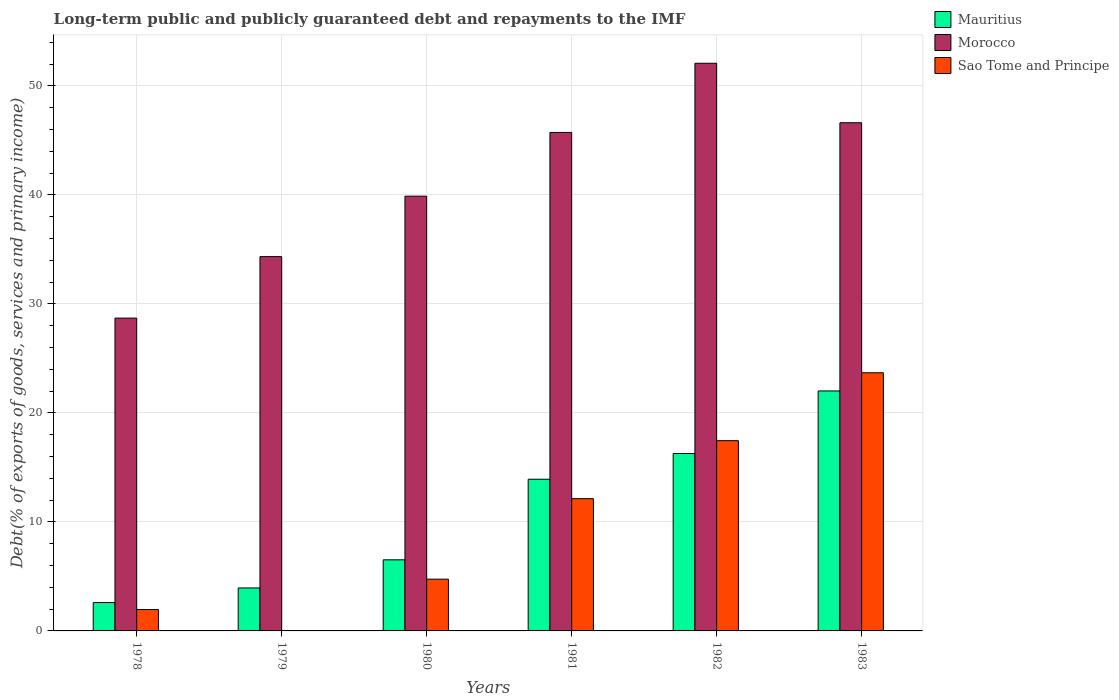How many bars are there on the 4th tick from the left?
Ensure brevity in your answer.  3. What is the label of the 2nd group of bars from the left?
Provide a short and direct response. 1979. In how many cases, is the number of bars for a given year not equal to the number of legend labels?
Make the answer very short. 0. What is the debt and repayments in Morocco in 1982?
Your response must be concise. 52.08. Across all years, what is the maximum debt and repayments in Sao Tome and Principe?
Give a very brief answer. 23.69. Across all years, what is the minimum debt and repayments in Sao Tome and Principe?
Ensure brevity in your answer.  0.01. In which year was the debt and repayments in Sao Tome and Principe minimum?
Give a very brief answer. 1979. What is the total debt and repayments in Sao Tome and Principe in the graph?
Offer a very short reply. 60. What is the difference between the debt and repayments in Morocco in 1982 and that in 1983?
Offer a very short reply. 5.46. What is the difference between the debt and repayments in Mauritius in 1981 and the debt and repayments in Morocco in 1979?
Your response must be concise. -20.42. What is the average debt and repayments in Mauritius per year?
Give a very brief answer. 10.88. In the year 1978, what is the difference between the debt and repayments in Morocco and debt and repayments in Sao Tome and Principe?
Offer a terse response. 26.74. What is the ratio of the debt and repayments in Mauritius in 1978 to that in 1982?
Ensure brevity in your answer.  0.16. Is the difference between the debt and repayments in Morocco in 1979 and 1983 greater than the difference between the debt and repayments in Sao Tome and Principe in 1979 and 1983?
Your answer should be very brief. Yes. What is the difference between the highest and the second highest debt and repayments in Sao Tome and Principe?
Ensure brevity in your answer.  6.23. What is the difference between the highest and the lowest debt and repayments in Morocco?
Your answer should be very brief. 23.38. In how many years, is the debt and repayments in Sao Tome and Principe greater than the average debt and repayments in Sao Tome and Principe taken over all years?
Make the answer very short. 3. Is the sum of the debt and repayments in Sao Tome and Principe in 1980 and 1981 greater than the maximum debt and repayments in Morocco across all years?
Ensure brevity in your answer.  No. What does the 3rd bar from the left in 1982 represents?
Your answer should be very brief. Sao Tome and Principe. What does the 2nd bar from the right in 1979 represents?
Your answer should be very brief. Morocco. Is it the case that in every year, the sum of the debt and repayments in Morocco and debt and repayments in Sao Tome and Principe is greater than the debt and repayments in Mauritius?
Offer a terse response. Yes. How many years are there in the graph?
Ensure brevity in your answer.  6. Where does the legend appear in the graph?
Offer a terse response. Top right. What is the title of the graph?
Make the answer very short. Long-term public and publicly guaranteed debt and repayments to the IMF. What is the label or title of the X-axis?
Keep it short and to the point. Years. What is the label or title of the Y-axis?
Offer a terse response. Debt(% of exports of goods, services and primary income). What is the Debt(% of exports of goods, services and primary income) in Mauritius in 1978?
Provide a short and direct response. 2.6. What is the Debt(% of exports of goods, services and primary income) in Morocco in 1978?
Provide a short and direct response. 28.7. What is the Debt(% of exports of goods, services and primary income) of Sao Tome and Principe in 1978?
Your response must be concise. 1.96. What is the Debt(% of exports of goods, services and primary income) in Mauritius in 1979?
Keep it short and to the point. 3.94. What is the Debt(% of exports of goods, services and primary income) in Morocco in 1979?
Offer a very short reply. 34.34. What is the Debt(% of exports of goods, services and primary income) of Sao Tome and Principe in 1979?
Your answer should be compact. 0.01. What is the Debt(% of exports of goods, services and primary income) of Mauritius in 1980?
Provide a short and direct response. 6.52. What is the Debt(% of exports of goods, services and primary income) in Morocco in 1980?
Your answer should be compact. 39.89. What is the Debt(% of exports of goods, services and primary income) in Sao Tome and Principe in 1980?
Provide a short and direct response. 4.75. What is the Debt(% of exports of goods, services and primary income) in Mauritius in 1981?
Offer a terse response. 13.92. What is the Debt(% of exports of goods, services and primary income) in Morocco in 1981?
Your answer should be compact. 45.74. What is the Debt(% of exports of goods, services and primary income) in Sao Tome and Principe in 1981?
Give a very brief answer. 12.14. What is the Debt(% of exports of goods, services and primary income) in Mauritius in 1982?
Offer a terse response. 16.28. What is the Debt(% of exports of goods, services and primary income) in Morocco in 1982?
Your answer should be compact. 52.08. What is the Debt(% of exports of goods, services and primary income) in Sao Tome and Principe in 1982?
Provide a succinct answer. 17.46. What is the Debt(% of exports of goods, services and primary income) in Mauritius in 1983?
Keep it short and to the point. 22.02. What is the Debt(% of exports of goods, services and primary income) of Morocco in 1983?
Your answer should be compact. 46.63. What is the Debt(% of exports of goods, services and primary income) in Sao Tome and Principe in 1983?
Make the answer very short. 23.69. Across all years, what is the maximum Debt(% of exports of goods, services and primary income) of Mauritius?
Give a very brief answer. 22.02. Across all years, what is the maximum Debt(% of exports of goods, services and primary income) of Morocco?
Provide a short and direct response. 52.08. Across all years, what is the maximum Debt(% of exports of goods, services and primary income) in Sao Tome and Principe?
Make the answer very short. 23.69. Across all years, what is the minimum Debt(% of exports of goods, services and primary income) of Mauritius?
Give a very brief answer. 2.6. Across all years, what is the minimum Debt(% of exports of goods, services and primary income) of Morocco?
Provide a succinct answer. 28.7. Across all years, what is the minimum Debt(% of exports of goods, services and primary income) in Sao Tome and Principe?
Make the answer very short. 0.01. What is the total Debt(% of exports of goods, services and primary income) of Mauritius in the graph?
Make the answer very short. 65.28. What is the total Debt(% of exports of goods, services and primary income) of Morocco in the graph?
Keep it short and to the point. 247.38. What is the total Debt(% of exports of goods, services and primary income) in Sao Tome and Principe in the graph?
Your answer should be compact. 60. What is the difference between the Debt(% of exports of goods, services and primary income) of Mauritius in 1978 and that in 1979?
Offer a terse response. -1.34. What is the difference between the Debt(% of exports of goods, services and primary income) in Morocco in 1978 and that in 1979?
Your answer should be compact. -5.64. What is the difference between the Debt(% of exports of goods, services and primary income) of Sao Tome and Principe in 1978 and that in 1979?
Your answer should be very brief. 1.95. What is the difference between the Debt(% of exports of goods, services and primary income) of Mauritius in 1978 and that in 1980?
Make the answer very short. -3.92. What is the difference between the Debt(% of exports of goods, services and primary income) in Morocco in 1978 and that in 1980?
Offer a very short reply. -11.19. What is the difference between the Debt(% of exports of goods, services and primary income) of Sao Tome and Principe in 1978 and that in 1980?
Your response must be concise. -2.79. What is the difference between the Debt(% of exports of goods, services and primary income) in Mauritius in 1978 and that in 1981?
Offer a terse response. -11.32. What is the difference between the Debt(% of exports of goods, services and primary income) in Morocco in 1978 and that in 1981?
Keep it short and to the point. -17.04. What is the difference between the Debt(% of exports of goods, services and primary income) of Sao Tome and Principe in 1978 and that in 1981?
Provide a succinct answer. -10.18. What is the difference between the Debt(% of exports of goods, services and primary income) in Mauritius in 1978 and that in 1982?
Your answer should be very brief. -13.68. What is the difference between the Debt(% of exports of goods, services and primary income) in Morocco in 1978 and that in 1982?
Offer a very short reply. -23.38. What is the difference between the Debt(% of exports of goods, services and primary income) in Sao Tome and Principe in 1978 and that in 1982?
Make the answer very short. -15.49. What is the difference between the Debt(% of exports of goods, services and primary income) of Mauritius in 1978 and that in 1983?
Keep it short and to the point. -19.42. What is the difference between the Debt(% of exports of goods, services and primary income) of Morocco in 1978 and that in 1983?
Provide a succinct answer. -17.93. What is the difference between the Debt(% of exports of goods, services and primary income) of Sao Tome and Principe in 1978 and that in 1983?
Offer a terse response. -21.73. What is the difference between the Debt(% of exports of goods, services and primary income) in Mauritius in 1979 and that in 1980?
Ensure brevity in your answer.  -2.58. What is the difference between the Debt(% of exports of goods, services and primary income) of Morocco in 1979 and that in 1980?
Give a very brief answer. -5.55. What is the difference between the Debt(% of exports of goods, services and primary income) in Sao Tome and Principe in 1979 and that in 1980?
Make the answer very short. -4.74. What is the difference between the Debt(% of exports of goods, services and primary income) of Mauritius in 1979 and that in 1981?
Provide a short and direct response. -9.98. What is the difference between the Debt(% of exports of goods, services and primary income) in Morocco in 1979 and that in 1981?
Offer a very short reply. -11.4. What is the difference between the Debt(% of exports of goods, services and primary income) of Sao Tome and Principe in 1979 and that in 1981?
Your answer should be compact. -12.13. What is the difference between the Debt(% of exports of goods, services and primary income) in Mauritius in 1979 and that in 1982?
Your answer should be very brief. -12.34. What is the difference between the Debt(% of exports of goods, services and primary income) of Morocco in 1979 and that in 1982?
Provide a short and direct response. -17.74. What is the difference between the Debt(% of exports of goods, services and primary income) in Sao Tome and Principe in 1979 and that in 1982?
Offer a terse response. -17.45. What is the difference between the Debt(% of exports of goods, services and primary income) in Mauritius in 1979 and that in 1983?
Keep it short and to the point. -18.08. What is the difference between the Debt(% of exports of goods, services and primary income) of Morocco in 1979 and that in 1983?
Your answer should be very brief. -12.28. What is the difference between the Debt(% of exports of goods, services and primary income) of Sao Tome and Principe in 1979 and that in 1983?
Keep it short and to the point. -23.68. What is the difference between the Debt(% of exports of goods, services and primary income) of Mauritius in 1980 and that in 1981?
Provide a short and direct response. -7.39. What is the difference between the Debt(% of exports of goods, services and primary income) of Morocco in 1980 and that in 1981?
Offer a very short reply. -5.85. What is the difference between the Debt(% of exports of goods, services and primary income) in Sao Tome and Principe in 1980 and that in 1981?
Make the answer very short. -7.39. What is the difference between the Debt(% of exports of goods, services and primary income) in Mauritius in 1980 and that in 1982?
Offer a very short reply. -9.75. What is the difference between the Debt(% of exports of goods, services and primary income) in Morocco in 1980 and that in 1982?
Provide a short and direct response. -12.2. What is the difference between the Debt(% of exports of goods, services and primary income) in Sao Tome and Principe in 1980 and that in 1982?
Keep it short and to the point. -12.71. What is the difference between the Debt(% of exports of goods, services and primary income) of Mauritius in 1980 and that in 1983?
Provide a short and direct response. -15.49. What is the difference between the Debt(% of exports of goods, services and primary income) in Morocco in 1980 and that in 1983?
Ensure brevity in your answer.  -6.74. What is the difference between the Debt(% of exports of goods, services and primary income) in Sao Tome and Principe in 1980 and that in 1983?
Your answer should be very brief. -18.94. What is the difference between the Debt(% of exports of goods, services and primary income) in Mauritius in 1981 and that in 1982?
Your response must be concise. -2.36. What is the difference between the Debt(% of exports of goods, services and primary income) in Morocco in 1981 and that in 1982?
Your answer should be compact. -6.35. What is the difference between the Debt(% of exports of goods, services and primary income) in Sao Tome and Principe in 1981 and that in 1982?
Provide a succinct answer. -5.32. What is the difference between the Debt(% of exports of goods, services and primary income) in Mauritius in 1981 and that in 1983?
Provide a short and direct response. -8.1. What is the difference between the Debt(% of exports of goods, services and primary income) in Morocco in 1981 and that in 1983?
Offer a terse response. -0.89. What is the difference between the Debt(% of exports of goods, services and primary income) in Sao Tome and Principe in 1981 and that in 1983?
Give a very brief answer. -11.55. What is the difference between the Debt(% of exports of goods, services and primary income) in Mauritius in 1982 and that in 1983?
Your answer should be very brief. -5.74. What is the difference between the Debt(% of exports of goods, services and primary income) of Morocco in 1982 and that in 1983?
Make the answer very short. 5.46. What is the difference between the Debt(% of exports of goods, services and primary income) of Sao Tome and Principe in 1982 and that in 1983?
Keep it short and to the point. -6.23. What is the difference between the Debt(% of exports of goods, services and primary income) in Mauritius in 1978 and the Debt(% of exports of goods, services and primary income) in Morocco in 1979?
Your response must be concise. -31.74. What is the difference between the Debt(% of exports of goods, services and primary income) of Mauritius in 1978 and the Debt(% of exports of goods, services and primary income) of Sao Tome and Principe in 1979?
Offer a very short reply. 2.6. What is the difference between the Debt(% of exports of goods, services and primary income) of Morocco in 1978 and the Debt(% of exports of goods, services and primary income) of Sao Tome and Principe in 1979?
Provide a succinct answer. 28.7. What is the difference between the Debt(% of exports of goods, services and primary income) of Mauritius in 1978 and the Debt(% of exports of goods, services and primary income) of Morocco in 1980?
Your answer should be compact. -37.29. What is the difference between the Debt(% of exports of goods, services and primary income) of Mauritius in 1978 and the Debt(% of exports of goods, services and primary income) of Sao Tome and Principe in 1980?
Keep it short and to the point. -2.15. What is the difference between the Debt(% of exports of goods, services and primary income) of Morocco in 1978 and the Debt(% of exports of goods, services and primary income) of Sao Tome and Principe in 1980?
Offer a very short reply. 23.95. What is the difference between the Debt(% of exports of goods, services and primary income) of Mauritius in 1978 and the Debt(% of exports of goods, services and primary income) of Morocco in 1981?
Your response must be concise. -43.14. What is the difference between the Debt(% of exports of goods, services and primary income) of Mauritius in 1978 and the Debt(% of exports of goods, services and primary income) of Sao Tome and Principe in 1981?
Ensure brevity in your answer.  -9.54. What is the difference between the Debt(% of exports of goods, services and primary income) in Morocco in 1978 and the Debt(% of exports of goods, services and primary income) in Sao Tome and Principe in 1981?
Make the answer very short. 16.57. What is the difference between the Debt(% of exports of goods, services and primary income) of Mauritius in 1978 and the Debt(% of exports of goods, services and primary income) of Morocco in 1982?
Your answer should be compact. -49.48. What is the difference between the Debt(% of exports of goods, services and primary income) of Mauritius in 1978 and the Debt(% of exports of goods, services and primary income) of Sao Tome and Principe in 1982?
Keep it short and to the point. -14.85. What is the difference between the Debt(% of exports of goods, services and primary income) in Morocco in 1978 and the Debt(% of exports of goods, services and primary income) in Sao Tome and Principe in 1982?
Your response must be concise. 11.25. What is the difference between the Debt(% of exports of goods, services and primary income) of Mauritius in 1978 and the Debt(% of exports of goods, services and primary income) of Morocco in 1983?
Give a very brief answer. -44.03. What is the difference between the Debt(% of exports of goods, services and primary income) of Mauritius in 1978 and the Debt(% of exports of goods, services and primary income) of Sao Tome and Principe in 1983?
Your answer should be compact. -21.09. What is the difference between the Debt(% of exports of goods, services and primary income) in Morocco in 1978 and the Debt(% of exports of goods, services and primary income) in Sao Tome and Principe in 1983?
Your response must be concise. 5.01. What is the difference between the Debt(% of exports of goods, services and primary income) of Mauritius in 1979 and the Debt(% of exports of goods, services and primary income) of Morocco in 1980?
Keep it short and to the point. -35.94. What is the difference between the Debt(% of exports of goods, services and primary income) in Mauritius in 1979 and the Debt(% of exports of goods, services and primary income) in Sao Tome and Principe in 1980?
Ensure brevity in your answer.  -0.81. What is the difference between the Debt(% of exports of goods, services and primary income) of Morocco in 1979 and the Debt(% of exports of goods, services and primary income) of Sao Tome and Principe in 1980?
Provide a short and direct response. 29.59. What is the difference between the Debt(% of exports of goods, services and primary income) of Mauritius in 1979 and the Debt(% of exports of goods, services and primary income) of Morocco in 1981?
Your response must be concise. -41.79. What is the difference between the Debt(% of exports of goods, services and primary income) of Mauritius in 1979 and the Debt(% of exports of goods, services and primary income) of Sao Tome and Principe in 1981?
Offer a terse response. -8.19. What is the difference between the Debt(% of exports of goods, services and primary income) in Morocco in 1979 and the Debt(% of exports of goods, services and primary income) in Sao Tome and Principe in 1981?
Your response must be concise. 22.21. What is the difference between the Debt(% of exports of goods, services and primary income) in Mauritius in 1979 and the Debt(% of exports of goods, services and primary income) in Morocco in 1982?
Make the answer very short. -48.14. What is the difference between the Debt(% of exports of goods, services and primary income) of Mauritius in 1979 and the Debt(% of exports of goods, services and primary income) of Sao Tome and Principe in 1982?
Provide a short and direct response. -13.51. What is the difference between the Debt(% of exports of goods, services and primary income) of Morocco in 1979 and the Debt(% of exports of goods, services and primary income) of Sao Tome and Principe in 1982?
Keep it short and to the point. 16.89. What is the difference between the Debt(% of exports of goods, services and primary income) of Mauritius in 1979 and the Debt(% of exports of goods, services and primary income) of Morocco in 1983?
Your answer should be very brief. -42.68. What is the difference between the Debt(% of exports of goods, services and primary income) in Mauritius in 1979 and the Debt(% of exports of goods, services and primary income) in Sao Tome and Principe in 1983?
Make the answer very short. -19.74. What is the difference between the Debt(% of exports of goods, services and primary income) of Morocco in 1979 and the Debt(% of exports of goods, services and primary income) of Sao Tome and Principe in 1983?
Provide a succinct answer. 10.66. What is the difference between the Debt(% of exports of goods, services and primary income) of Mauritius in 1980 and the Debt(% of exports of goods, services and primary income) of Morocco in 1981?
Ensure brevity in your answer.  -39.21. What is the difference between the Debt(% of exports of goods, services and primary income) of Mauritius in 1980 and the Debt(% of exports of goods, services and primary income) of Sao Tome and Principe in 1981?
Your answer should be compact. -5.61. What is the difference between the Debt(% of exports of goods, services and primary income) in Morocco in 1980 and the Debt(% of exports of goods, services and primary income) in Sao Tome and Principe in 1981?
Your answer should be compact. 27.75. What is the difference between the Debt(% of exports of goods, services and primary income) of Mauritius in 1980 and the Debt(% of exports of goods, services and primary income) of Morocco in 1982?
Provide a short and direct response. -45.56. What is the difference between the Debt(% of exports of goods, services and primary income) of Mauritius in 1980 and the Debt(% of exports of goods, services and primary income) of Sao Tome and Principe in 1982?
Give a very brief answer. -10.93. What is the difference between the Debt(% of exports of goods, services and primary income) in Morocco in 1980 and the Debt(% of exports of goods, services and primary income) in Sao Tome and Principe in 1982?
Provide a short and direct response. 22.43. What is the difference between the Debt(% of exports of goods, services and primary income) of Mauritius in 1980 and the Debt(% of exports of goods, services and primary income) of Morocco in 1983?
Provide a succinct answer. -40.1. What is the difference between the Debt(% of exports of goods, services and primary income) of Mauritius in 1980 and the Debt(% of exports of goods, services and primary income) of Sao Tome and Principe in 1983?
Offer a very short reply. -17.16. What is the difference between the Debt(% of exports of goods, services and primary income) in Morocco in 1980 and the Debt(% of exports of goods, services and primary income) in Sao Tome and Principe in 1983?
Keep it short and to the point. 16.2. What is the difference between the Debt(% of exports of goods, services and primary income) in Mauritius in 1981 and the Debt(% of exports of goods, services and primary income) in Morocco in 1982?
Your answer should be compact. -38.17. What is the difference between the Debt(% of exports of goods, services and primary income) of Mauritius in 1981 and the Debt(% of exports of goods, services and primary income) of Sao Tome and Principe in 1982?
Your answer should be very brief. -3.54. What is the difference between the Debt(% of exports of goods, services and primary income) of Morocco in 1981 and the Debt(% of exports of goods, services and primary income) of Sao Tome and Principe in 1982?
Make the answer very short. 28.28. What is the difference between the Debt(% of exports of goods, services and primary income) in Mauritius in 1981 and the Debt(% of exports of goods, services and primary income) in Morocco in 1983?
Your answer should be very brief. -32.71. What is the difference between the Debt(% of exports of goods, services and primary income) of Mauritius in 1981 and the Debt(% of exports of goods, services and primary income) of Sao Tome and Principe in 1983?
Your answer should be compact. -9.77. What is the difference between the Debt(% of exports of goods, services and primary income) of Morocco in 1981 and the Debt(% of exports of goods, services and primary income) of Sao Tome and Principe in 1983?
Offer a terse response. 22.05. What is the difference between the Debt(% of exports of goods, services and primary income) of Mauritius in 1982 and the Debt(% of exports of goods, services and primary income) of Morocco in 1983?
Your answer should be very brief. -30.35. What is the difference between the Debt(% of exports of goods, services and primary income) in Mauritius in 1982 and the Debt(% of exports of goods, services and primary income) in Sao Tome and Principe in 1983?
Make the answer very short. -7.41. What is the difference between the Debt(% of exports of goods, services and primary income) in Morocco in 1982 and the Debt(% of exports of goods, services and primary income) in Sao Tome and Principe in 1983?
Ensure brevity in your answer.  28.4. What is the average Debt(% of exports of goods, services and primary income) of Mauritius per year?
Make the answer very short. 10.88. What is the average Debt(% of exports of goods, services and primary income) of Morocco per year?
Offer a very short reply. 41.23. What is the average Debt(% of exports of goods, services and primary income) in Sao Tome and Principe per year?
Your answer should be compact. 10. In the year 1978, what is the difference between the Debt(% of exports of goods, services and primary income) of Mauritius and Debt(% of exports of goods, services and primary income) of Morocco?
Offer a terse response. -26.1. In the year 1978, what is the difference between the Debt(% of exports of goods, services and primary income) in Mauritius and Debt(% of exports of goods, services and primary income) in Sao Tome and Principe?
Give a very brief answer. 0.64. In the year 1978, what is the difference between the Debt(% of exports of goods, services and primary income) of Morocco and Debt(% of exports of goods, services and primary income) of Sao Tome and Principe?
Offer a terse response. 26.74. In the year 1979, what is the difference between the Debt(% of exports of goods, services and primary income) of Mauritius and Debt(% of exports of goods, services and primary income) of Morocco?
Keep it short and to the point. -30.4. In the year 1979, what is the difference between the Debt(% of exports of goods, services and primary income) in Mauritius and Debt(% of exports of goods, services and primary income) in Sao Tome and Principe?
Offer a terse response. 3.94. In the year 1979, what is the difference between the Debt(% of exports of goods, services and primary income) of Morocco and Debt(% of exports of goods, services and primary income) of Sao Tome and Principe?
Offer a very short reply. 34.34. In the year 1980, what is the difference between the Debt(% of exports of goods, services and primary income) in Mauritius and Debt(% of exports of goods, services and primary income) in Morocco?
Provide a short and direct response. -33.36. In the year 1980, what is the difference between the Debt(% of exports of goods, services and primary income) of Mauritius and Debt(% of exports of goods, services and primary income) of Sao Tome and Principe?
Provide a short and direct response. 1.78. In the year 1980, what is the difference between the Debt(% of exports of goods, services and primary income) of Morocco and Debt(% of exports of goods, services and primary income) of Sao Tome and Principe?
Provide a succinct answer. 35.14. In the year 1981, what is the difference between the Debt(% of exports of goods, services and primary income) of Mauritius and Debt(% of exports of goods, services and primary income) of Morocco?
Keep it short and to the point. -31.82. In the year 1981, what is the difference between the Debt(% of exports of goods, services and primary income) in Mauritius and Debt(% of exports of goods, services and primary income) in Sao Tome and Principe?
Offer a very short reply. 1.78. In the year 1981, what is the difference between the Debt(% of exports of goods, services and primary income) in Morocco and Debt(% of exports of goods, services and primary income) in Sao Tome and Principe?
Your answer should be very brief. 33.6. In the year 1982, what is the difference between the Debt(% of exports of goods, services and primary income) of Mauritius and Debt(% of exports of goods, services and primary income) of Morocco?
Your response must be concise. -35.81. In the year 1982, what is the difference between the Debt(% of exports of goods, services and primary income) of Mauritius and Debt(% of exports of goods, services and primary income) of Sao Tome and Principe?
Offer a terse response. -1.18. In the year 1982, what is the difference between the Debt(% of exports of goods, services and primary income) of Morocco and Debt(% of exports of goods, services and primary income) of Sao Tome and Principe?
Your answer should be compact. 34.63. In the year 1983, what is the difference between the Debt(% of exports of goods, services and primary income) in Mauritius and Debt(% of exports of goods, services and primary income) in Morocco?
Your answer should be compact. -24.61. In the year 1983, what is the difference between the Debt(% of exports of goods, services and primary income) in Mauritius and Debt(% of exports of goods, services and primary income) in Sao Tome and Principe?
Offer a terse response. -1.67. In the year 1983, what is the difference between the Debt(% of exports of goods, services and primary income) of Morocco and Debt(% of exports of goods, services and primary income) of Sao Tome and Principe?
Ensure brevity in your answer.  22.94. What is the ratio of the Debt(% of exports of goods, services and primary income) in Mauritius in 1978 to that in 1979?
Provide a short and direct response. 0.66. What is the ratio of the Debt(% of exports of goods, services and primary income) in Morocco in 1978 to that in 1979?
Your answer should be very brief. 0.84. What is the ratio of the Debt(% of exports of goods, services and primary income) of Sao Tome and Principe in 1978 to that in 1979?
Your answer should be compact. 307.85. What is the ratio of the Debt(% of exports of goods, services and primary income) of Mauritius in 1978 to that in 1980?
Provide a succinct answer. 0.4. What is the ratio of the Debt(% of exports of goods, services and primary income) of Morocco in 1978 to that in 1980?
Your answer should be compact. 0.72. What is the ratio of the Debt(% of exports of goods, services and primary income) of Sao Tome and Principe in 1978 to that in 1980?
Give a very brief answer. 0.41. What is the ratio of the Debt(% of exports of goods, services and primary income) of Mauritius in 1978 to that in 1981?
Offer a very short reply. 0.19. What is the ratio of the Debt(% of exports of goods, services and primary income) of Morocco in 1978 to that in 1981?
Provide a succinct answer. 0.63. What is the ratio of the Debt(% of exports of goods, services and primary income) in Sao Tome and Principe in 1978 to that in 1981?
Your answer should be compact. 0.16. What is the ratio of the Debt(% of exports of goods, services and primary income) of Mauritius in 1978 to that in 1982?
Provide a short and direct response. 0.16. What is the ratio of the Debt(% of exports of goods, services and primary income) in Morocco in 1978 to that in 1982?
Give a very brief answer. 0.55. What is the ratio of the Debt(% of exports of goods, services and primary income) in Sao Tome and Principe in 1978 to that in 1982?
Your response must be concise. 0.11. What is the ratio of the Debt(% of exports of goods, services and primary income) in Mauritius in 1978 to that in 1983?
Make the answer very short. 0.12. What is the ratio of the Debt(% of exports of goods, services and primary income) in Morocco in 1978 to that in 1983?
Ensure brevity in your answer.  0.62. What is the ratio of the Debt(% of exports of goods, services and primary income) in Sao Tome and Principe in 1978 to that in 1983?
Provide a succinct answer. 0.08. What is the ratio of the Debt(% of exports of goods, services and primary income) in Mauritius in 1979 to that in 1980?
Give a very brief answer. 0.6. What is the ratio of the Debt(% of exports of goods, services and primary income) of Morocco in 1979 to that in 1980?
Ensure brevity in your answer.  0.86. What is the ratio of the Debt(% of exports of goods, services and primary income) in Sao Tome and Principe in 1979 to that in 1980?
Your response must be concise. 0. What is the ratio of the Debt(% of exports of goods, services and primary income) of Mauritius in 1979 to that in 1981?
Your answer should be compact. 0.28. What is the ratio of the Debt(% of exports of goods, services and primary income) in Morocco in 1979 to that in 1981?
Keep it short and to the point. 0.75. What is the ratio of the Debt(% of exports of goods, services and primary income) in Mauritius in 1979 to that in 1982?
Provide a succinct answer. 0.24. What is the ratio of the Debt(% of exports of goods, services and primary income) in Morocco in 1979 to that in 1982?
Your answer should be compact. 0.66. What is the ratio of the Debt(% of exports of goods, services and primary income) in Mauritius in 1979 to that in 1983?
Offer a very short reply. 0.18. What is the ratio of the Debt(% of exports of goods, services and primary income) of Morocco in 1979 to that in 1983?
Provide a short and direct response. 0.74. What is the ratio of the Debt(% of exports of goods, services and primary income) in Mauritius in 1980 to that in 1981?
Give a very brief answer. 0.47. What is the ratio of the Debt(% of exports of goods, services and primary income) of Morocco in 1980 to that in 1981?
Your response must be concise. 0.87. What is the ratio of the Debt(% of exports of goods, services and primary income) in Sao Tome and Principe in 1980 to that in 1981?
Keep it short and to the point. 0.39. What is the ratio of the Debt(% of exports of goods, services and primary income) of Mauritius in 1980 to that in 1982?
Your answer should be very brief. 0.4. What is the ratio of the Debt(% of exports of goods, services and primary income) in Morocco in 1980 to that in 1982?
Provide a short and direct response. 0.77. What is the ratio of the Debt(% of exports of goods, services and primary income) of Sao Tome and Principe in 1980 to that in 1982?
Provide a short and direct response. 0.27. What is the ratio of the Debt(% of exports of goods, services and primary income) in Mauritius in 1980 to that in 1983?
Ensure brevity in your answer.  0.3. What is the ratio of the Debt(% of exports of goods, services and primary income) in Morocco in 1980 to that in 1983?
Ensure brevity in your answer.  0.86. What is the ratio of the Debt(% of exports of goods, services and primary income) in Sao Tome and Principe in 1980 to that in 1983?
Your answer should be very brief. 0.2. What is the ratio of the Debt(% of exports of goods, services and primary income) in Mauritius in 1981 to that in 1982?
Give a very brief answer. 0.85. What is the ratio of the Debt(% of exports of goods, services and primary income) of Morocco in 1981 to that in 1982?
Offer a terse response. 0.88. What is the ratio of the Debt(% of exports of goods, services and primary income) of Sao Tome and Principe in 1981 to that in 1982?
Keep it short and to the point. 0.7. What is the ratio of the Debt(% of exports of goods, services and primary income) in Mauritius in 1981 to that in 1983?
Make the answer very short. 0.63. What is the ratio of the Debt(% of exports of goods, services and primary income) of Morocco in 1981 to that in 1983?
Your answer should be compact. 0.98. What is the ratio of the Debt(% of exports of goods, services and primary income) in Sao Tome and Principe in 1981 to that in 1983?
Offer a terse response. 0.51. What is the ratio of the Debt(% of exports of goods, services and primary income) in Mauritius in 1982 to that in 1983?
Keep it short and to the point. 0.74. What is the ratio of the Debt(% of exports of goods, services and primary income) of Morocco in 1982 to that in 1983?
Keep it short and to the point. 1.12. What is the ratio of the Debt(% of exports of goods, services and primary income) in Sao Tome and Principe in 1982 to that in 1983?
Offer a terse response. 0.74. What is the difference between the highest and the second highest Debt(% of exports of goods, services and primary income) of Mauritius?
Make the answer very short. 5.74. What is the difference between the highest and the second highest Debt(% of exports of goods, services and primary income) in Morocco?
Give a very brief answer. 5.46. What is the difference between the highest and the second highest Debt(% of exports of goods, services and primary income) of Sao Tome and Principe?
Offer a very short reply. 6.23. What is the difference between the highest and the lowest Debt(% of exports of goods, services and primary income) of Mauritius?
Offer a very short reply. 19.42. What is the difference between the highest and the lowest Debt(% of exports of goods, services and primary income) in Morocco?
Provide a succinct answer. 23.38. What is the difference between the highest and the lowest Debt(% of exports of goods, services and primary income) in Sao Tome and Principe?
Provide a short and direct response. 23.68. 